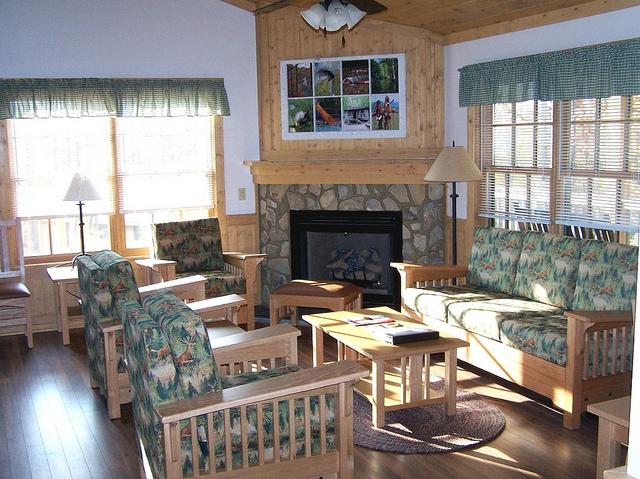What is the design on the cushion?
Give a very brief answer. Deer. Might this be a vacation home?
Short answer required. Yes. Is there a fire in the fireplace?
Give a very brief answer. No. 